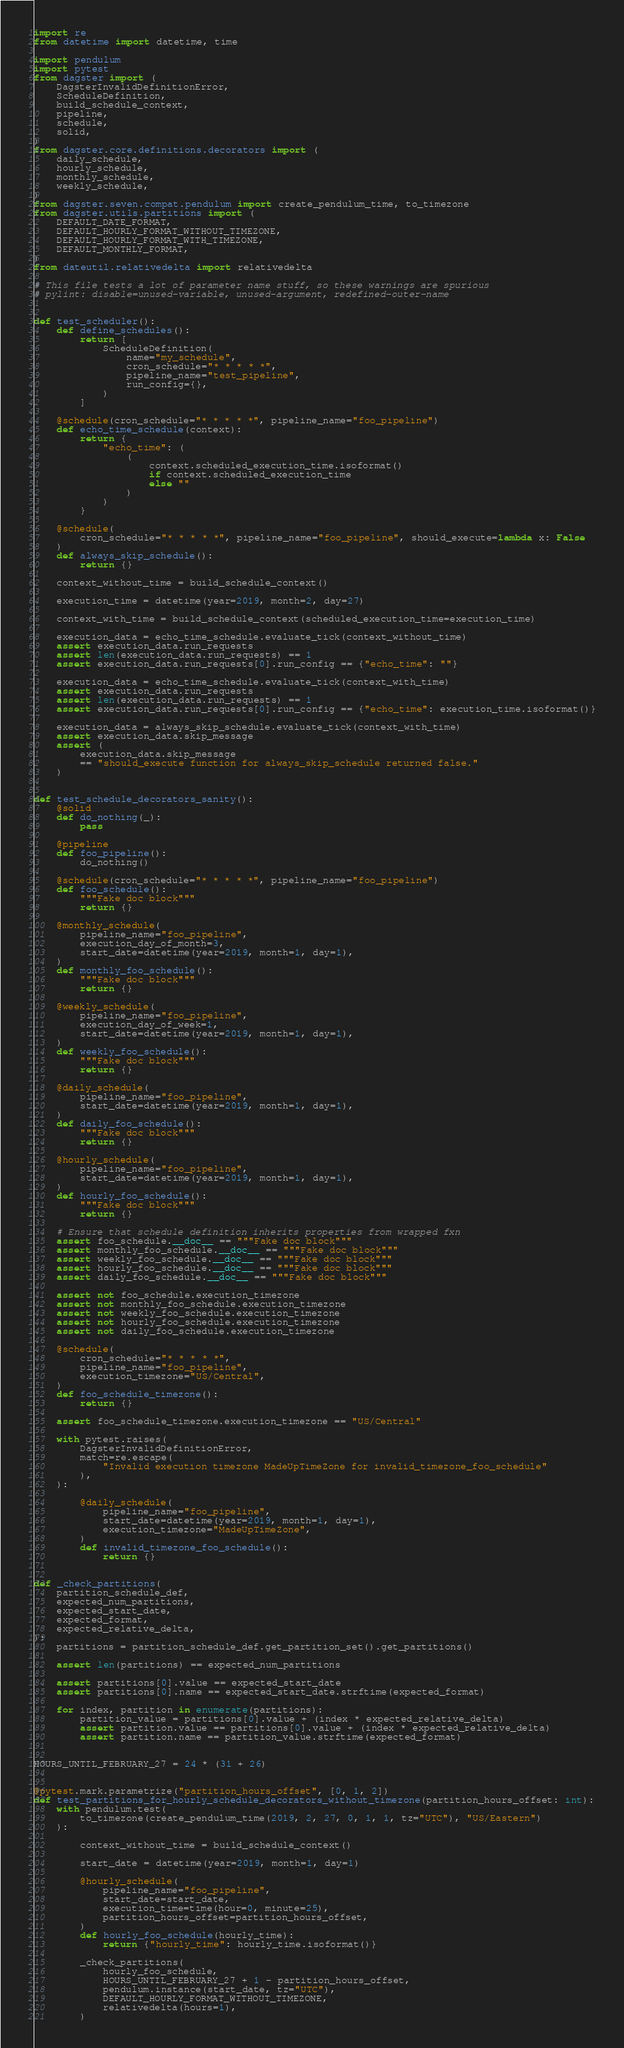Convert code to text. <code><loc_0><loc_0><loc_500><loc_500><_Python_>import re
from datetime import datetime, time

import pendulum
import pytest
from dagster import (
    DagsterInvalidDefinitionError,
    ScheduleDefinition,
    build_schedule_context,
    pipeline,
    schedule,
    solid,
)
from dagster.core.definitions.decorators import (
    daily_schedule,
    hourly_schedule,
    monthly_schedule,
    weekly_schedule,
)
from dagster.seven.compat.pendulum import create_pendulum_time, to_timezone
from dagster.utils.partitions import (
    DEFAULT_DATE_FORMAT,
    DEFAULT_HOURLY_FORMAT_WITHOUT_TIMEZONE,
    DEFAULT_HOURLY_FORMAT_WITH_TIMEZONE,
    DEFAULT_MONTHLY_FORMAT,
)
from dateutil.relativedelta import relativedelta

# This file tests a lot of parameter name stuff, so these warnings are spurious
# pylint: disable=unused-variable, unused-argument, redefined-outer-name


def test_scheduler():
    def define_schedules():
        return [
            ScheduleDefinition(
                name="my_schedule",
                cron_schedule="* * * * *",
                pipeline_name="test_pipeline",
                run_config={},
            )
        ]

    @schedule(cron_schedule="* * * * *", pipeline_name="foo_pipeline")
    def echo_time_schedule(context):
        return {
            "echo_time": (
                (
                    context.scheduled_execution_time.isoformat()
                    if context.scheduled_execution_time
                    else ""
                )
            )
        }

    @schedule(
        cron_schedule="* * * * *", pipeline_name="foo_pipeline", should_execute=lambda x: False
    )
    def always_skip_schedule():
        return {}

    context_without_time = build_schedule_context()

    execution_time = datetime(year=2019, month=2, day=27)

    context_with_time = build_schedule_context(scheduled_execution_time=execution_time)

    execution_data = echo_time_schedule.evaluate_tick(context_without_time)
    assert execution_data.run_requests
    assert len(execution_data.run_requests) == 1
    assert execution_data.run_requests[0].run_config == {"echo_time": ""}

    execution_data = echo_time_schedule.evaluate_tick(context_with_time)
    assert execution_data.run_requests
    assert len(execution_data.run_requests) == 1
    assert execution_data.run_requests[0].run_config == {"echo_time": execution_time.isoformat()}

    execution_data = always_skip_schedule.evaluate_tick(context_with_time)
    assert execution_data.skip_message
    assert (
        execution_data.skip_message
        == "should_execute function for always_skip_schedule returned false."
    )


def test_schedule_decorators_sanity():
    @solid
    def do_nothing(_):
        pass

    @pipeline
    def foo_pipeline():
        do_nothing()

    @schedule(cron_schedule="* * * * *", pipeline_name="foo_pipeline")
    def foo_schedule():
        """Fake doc block"""
        return {}

    @monthly_schedule(
        pipeline_name="foo_pipeline",
        execution_day_of_month=3,
        start_date=datetime(year=2019, month=1, day=1),
    )
    def monthly_foo_schedule():
        """Fake doc block"""
        return {}

    @weekly_schedule(
        pipeline_name="foo_pipeline",
        execution_day_of_week=1,
        start_date=datetime(year=2019, month=1, day=1),
    )
    def weekly_foo_schedule():
        """Fake doc block"""
        return {}

    @daily_schedule(
        pipeline_name="foo_pipeline",
        start_date=datetime(year=2019, month=1, day=1),
    )
    def daily_foo_schedule():
        """Fake doc block"""
        return {}

    @hourly_schedule(
        pipeline_name="foo_pipeline",
        start_date=datetime(year=2019, month=1, day=1),
    )
    def hourly_foo_schedule():
        """Fake doc block"""
        return {}

    # Ensure that schedule definition inherits properties from wrapped fxn
    assert foo_schedule.__doc__ == """Fake doc block"""
    assert monthly_foo_schedule.__doc__ == """Fake doc block"""
    assert weekly_foo_schedule.__doc__ == """Fake doc block"""
    assert hourly_foo_schedule.__doc__ == """Fake doc block"""
    assert daily_foo_schedule.__doc__ == """Fake doc block"""

    assert not foo_schedule.execution_timezone
    assert not monthly_foo_schedule.execution_timezone
    assert not weekly_foo_schedule.execution_timezone
    assert not hourly_foo_schedule.execution_timezone
    assert not daily_foo_schedule.execution_timezone

    @schedule(
        cron_schedule="* * * * *",
        pipeline_name="foo_pipeline",
        execution_timezone="US/Central",
    )
    def foo_schedule_timezone():
        return {}

    assert foo_schedule_timezone.execution_timezone == "US/Central"

    with pytest.raises(
        DagsterInvalidDefinitionError,
        match=re.escape(
            "Invalid execution timezone MadeUpTimeZone for invalid_timezone_foo_schedule"
        ),
    ):

        @daily_schedule(
            pipeline_name="foo_pipeline",
            start_date=datetime(year=2019, month=1, day=1),
            execution_timezone="MadeUpTimeZone",
        )
        def invalid_timezone_foo_schedule():
            return {}


def _check_partitions(
    partition_schedule_def,
    expected_num_partitions,
    expected_start_date,
    expected_format,
    expected_relative_delta,
):
    partitions = partition_schedule_def.get_partition_set().get_partitions()

    assert len(partitions) == expected_num_partitions

    assert partitions[0].value == expected_start_date
    assert partitions[0].name == expected_start_date.strftime(expected_format)

    for index, partition in enumerate(partitions):
        partition_value = partitions[0].value + (index * expected_relative_delta)
        assert partition.value == partitions[0].value + (index * expected_relative_delta)
        assert partition.name == partition_value.strftime(expected_format)


HOURS_UNTIL_FEBRUARY_27 = 24 * (31 + 26)


@pytest.mark.parametrize("partition_hours_offset", [0, 1, 2])
def test_partitions_for_hourly_schedule_decorators_without_timezone(partition_hours_offset: int):
    with pendulum.test(
        to_timezone(create_pendulum_time(2019, 2, 27, 0, 1, 1, tz="UTC"), "US/Eastern")
    ):

        context_without_time = build_schedule_context()

        start_date = datetime(year=2019, month=1, day=1)

        @hourly_schedule(
            pipeline_name="foo_pipeline",
            start_date=start_date,
            execution_time=time(hour=0, minute=25),
            partition_hours_offset=partition_hours_offset,
        )
        def hourly_foo_schedule(hourly_time):
            return {"hourly_time": hourly_time.isoformat()}

        _check_partitions(
            hourly_foo_schedule,
            HOURS_UNTIL_FEBRUARY_27 + 1 - partition_hours_offset,
            pendulum.instance(start_date, tz="UTC"),
            DEFAULT_HOURLY_FORMAT_WITHOUT_TIMEZONE,
            relativedelta(hours=1),
        )
</code> 